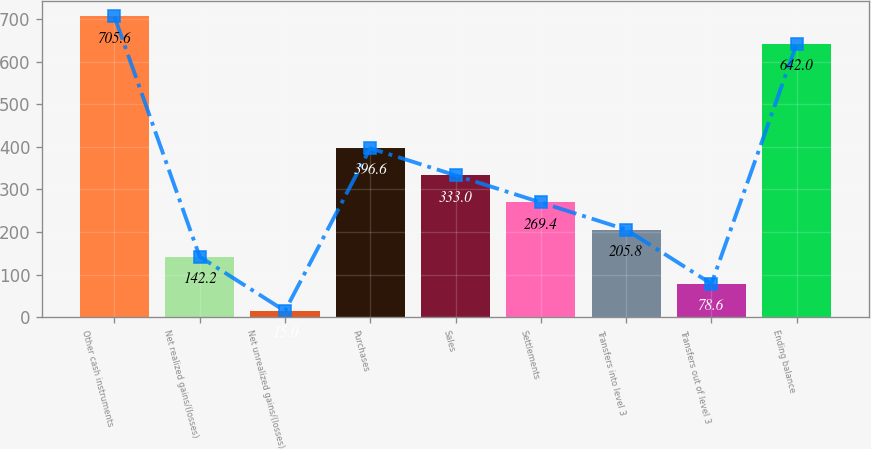Convert chart. <chart><loc_0><loc_0><loc_500><loc_500><bar_chart><fcel>Other cash instruments<fcel>Net realized gains/(losses)<fcel>Net unrealized gains/(losses)<fcel>Purchases<fcel>Sales<fcel>Settlements<fcel>Transfers into level 3<fcel>Transfers out of level 3<fcel>Ending balance<nl><fcel>705.6<fcel>142.2<fcel>15<fcel>396.6<fcel>333<fcel>269.4<fcel>205.8<fcel>78.6<fcel>642<nl></chart> 